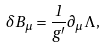<formula> <loc_0><loc_0><loc_500><loc_500>\delta B _ { \mu } = \frac { 1 } { g ^ { \prime } } \partial _ { \mu } \Lambda ,</formula> 